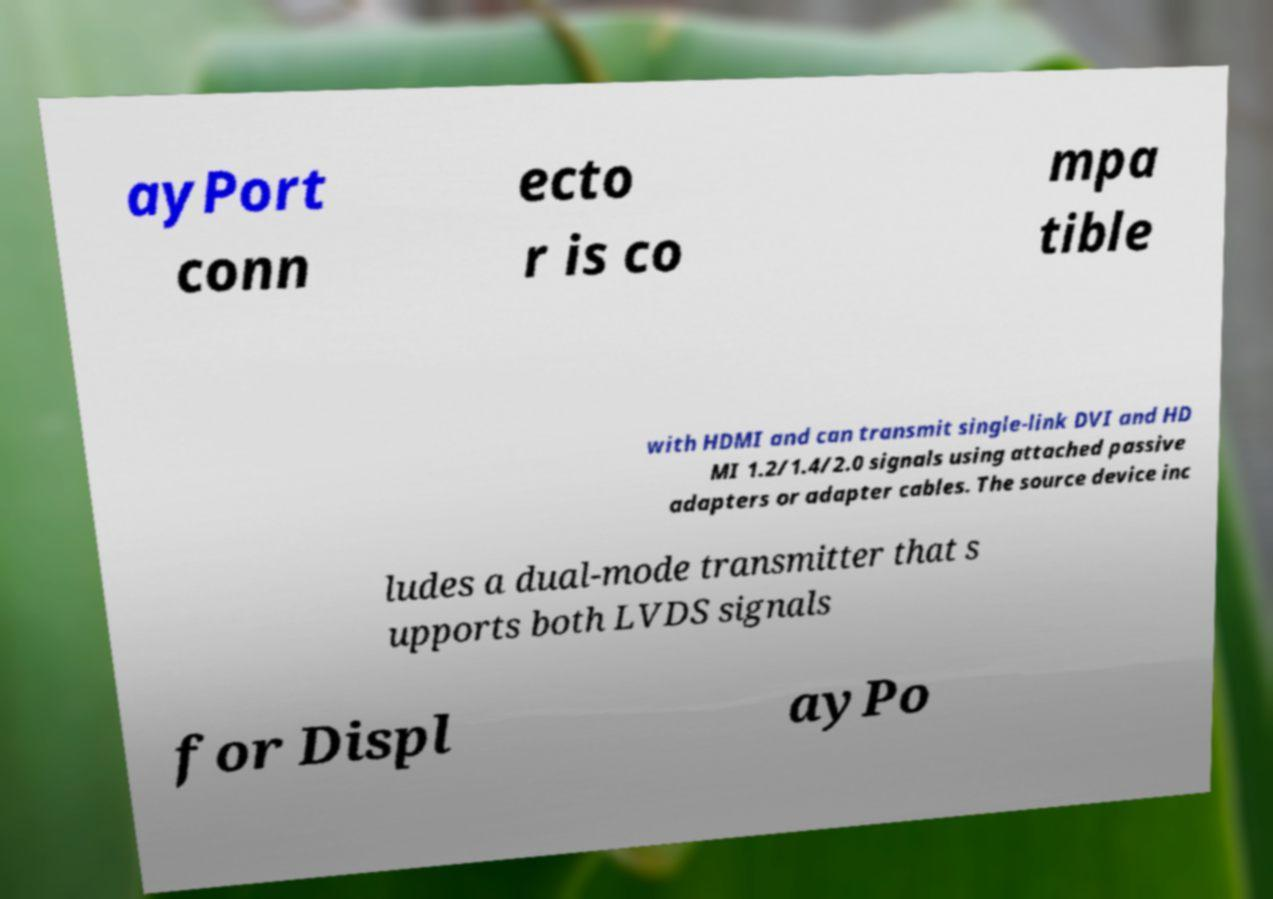There's text embedded in this image that I need extracted. Can you transcribe it verbatim? ayPort conn ecto r is co mpa tible with HDMI and can transmit single-link DVI and HD MI 1.2/1.4/2.0 signals using attached passive adapters or adapter cables. The source device inc ludes a dual-mode transmitter that s upports both LVDS signals for Displ ayPo 